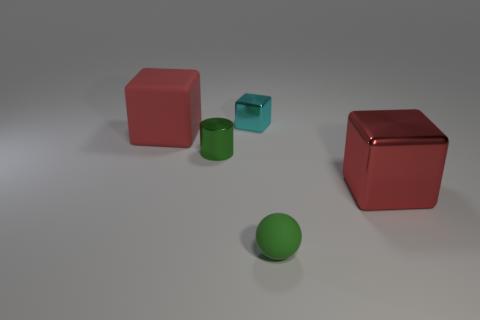Is there a tiny thing of the same color as the tiny ball?
Offer a terse response. Yes. What number of green things are large cubes or small blocks?
Offer a terse response. 0. What number of other things are there of the same size as the green shiny object?
Give a very brief answer. 2. How many tiny objects are green metallic cubes or red metallic objects?
Offer a very short reply. 0. Is the size of the red matte cube the same as the metallic cube that is in front of the green cylinder?
Provide a succinct answer. Yes. How many other things are the same shape as the cyan object?
Offer a terse response. 2. The large red object that is made of the same material as the small green cylinder is what shape?
Provide a succinct answer. Cube. Are any red metallic objects visible?
Offer a terse response. Yes. Are there fewer matte blocks that are right of the green matte object than shiny cubes that are behind the tiny metallic cylinder?
Offer a terse response. Yes. There is a red object behind the small green shiny cylinder; what shape is it?
Keep it short and to the point. Cube. 